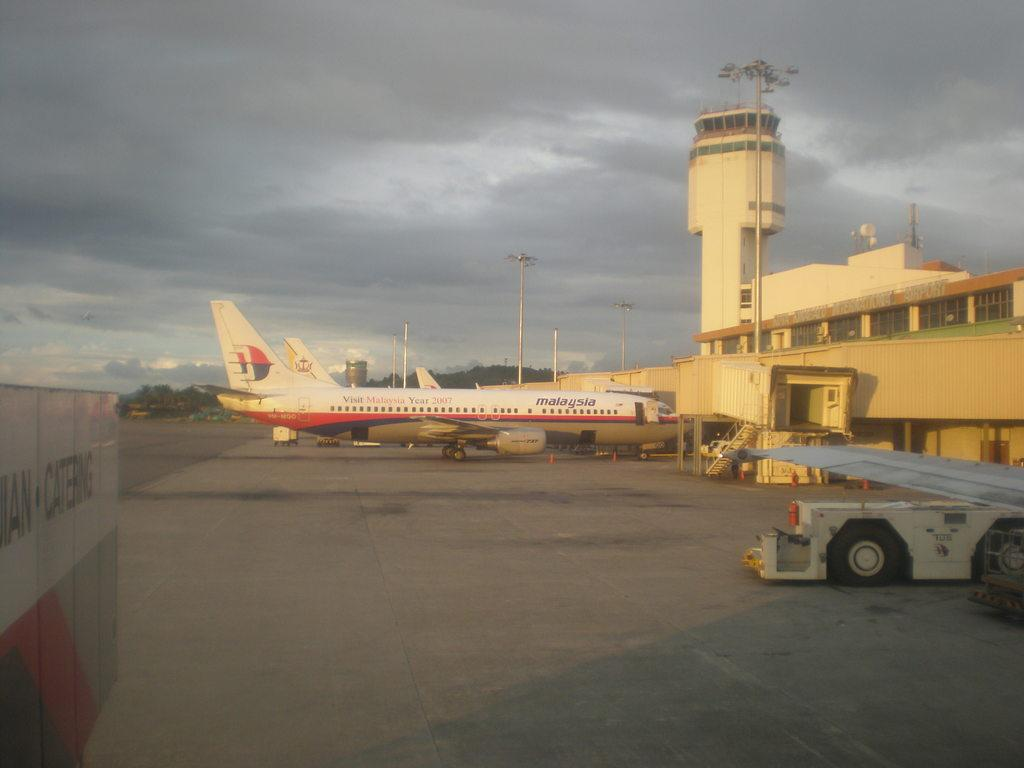What is the main subject of the image? The main subject of the image is an airplane. What can be seen in front of the airplane? There are buildings in front of the airplane. What else is present on the right side of the image? There is another vehicle on the right side of the image. What type of cream is being used to decorate the vase in the image? There is no vase or cream present in the image. What type of wool is being used to cover the airplane in the image? There is no wool present in the image; the airplane is not covered. 